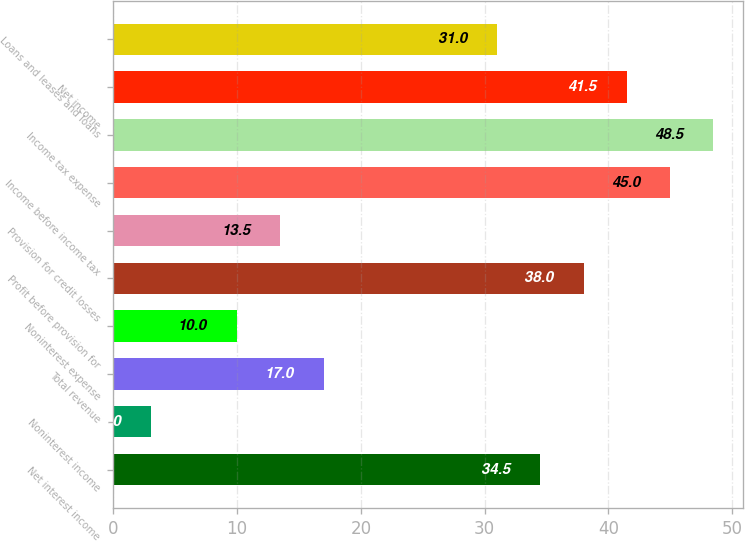<chart> <loc_0><loc_0><loc_500><loc_500><bar_chart><fcel>Net interest income<fcel>Noninterest income<fcel>Total revenue<fcel>Noninterest expense<fcel>Profit before provision for<fcel>Provision for credit losses<fcel>Income before income tax<fcel>Income tax expense<fcel>Net income<fcel>Loans and leases and loans<nl><fcel>34.5<fcel>3<fcel>17<fcel>10<fcel>38<fcel>13.5<fcel>45<fcel>48.5<fcel>41.5<fcel>31<nl></chart> 